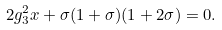Convert formula to latex. <formula><loc_0><loc_0><loc_500><loc_500>2 g _ { 3 } ^ { 2 } x + \sigma ( 1 + \sigma ) ( 1 + 2 \sigma ) = 0 .</formula> 